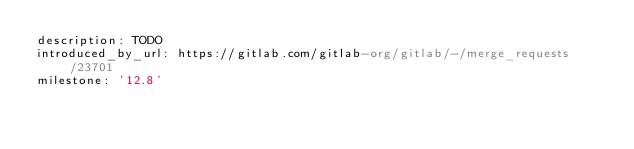Convert code to text. <code><loc_0><loc_0><loc_500><loc_500><_YAML_>description: TODO
introduced_by_url: https://gitlab.com/gitlab-org/gitlab/-/merge_requests/23701
milestone: '12.8'
</code> 